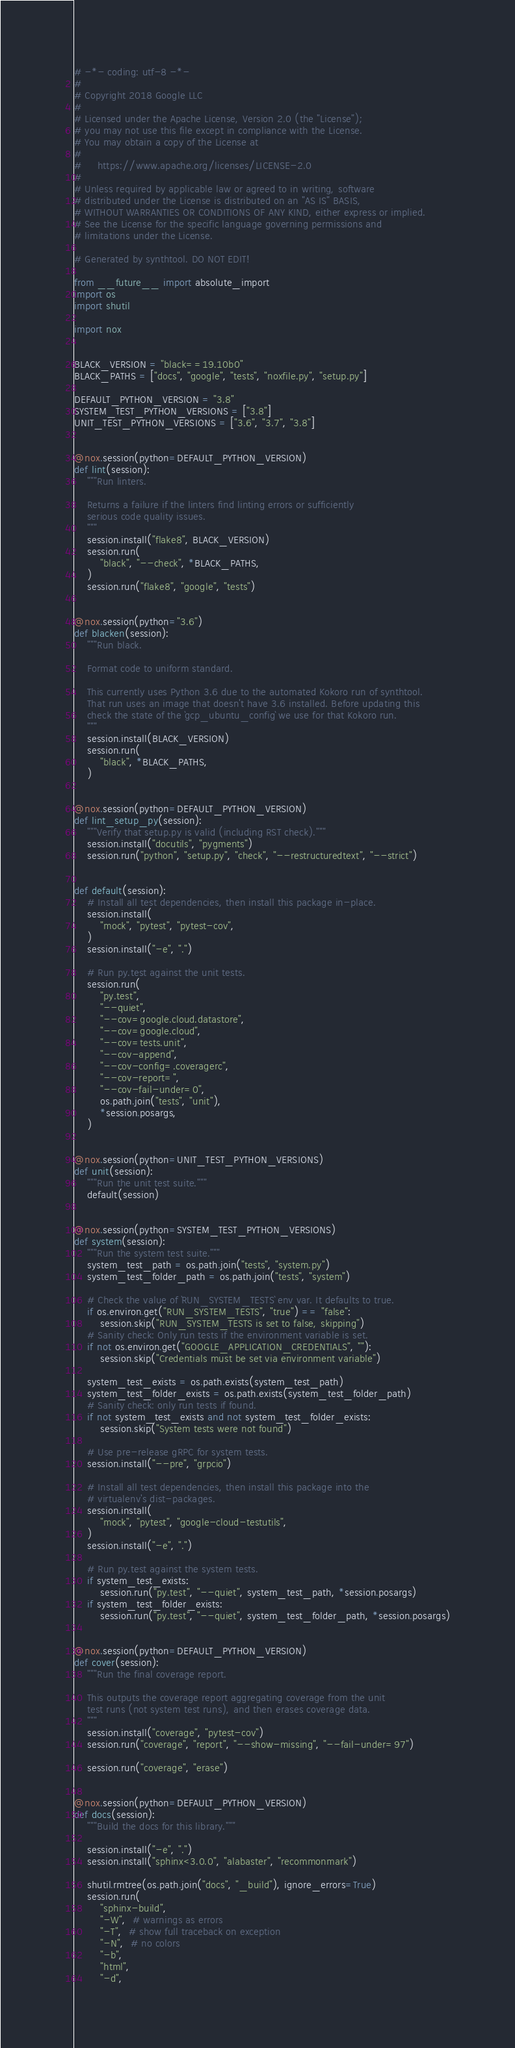<code> <loc_0><loc_0><loc_500><loc_500><_Python_># -*- coding: utf-8 -*-
#
# Copyright 2018 Google LLC
#
# Licensed under the Apache License, Version 2.0 (the "License");
# you may not use this file except in compliance with the License.
# You may obtain a copy of the License at
#
#     https://www.apache.org/licenses/LICENSE-2.0
#
# Unless required by applicable law or agreed to in writing, software
# distributed under the License is distributed on an "AS IS" BASIS,
# WITHOUT WARRANTIES OR CONDITIONS OF ANY KIND, either express or implied.
# See the License for the specific language governing permissions and
# limitations under the License.

# Generated by synthtool. DO NOT EDIT!

from __future__ import absolute_import
import os
import shutil

import nox


BLACK_VERSION = "black==19.10b0"
BLACK_PATHS = ["docs", "google", "tests", "noxfile.py", "setup.py"]

DEFAULT_PYTHON_VERSION = "3.8"
SYSTEM_TEST_PYTHON_VERSIONS = ["3.8"]
UNIT_TEST_PYTHON_VERSIONS = ["3.6", "3.7", "3.8"]


@nox.session(python=DEFAULT_PYTHON_VERSION)
def lint(session):
    """Run linters.

    Returns a failure if the linters find linting errors or sufficiently
    serious code quality issues.
    """
    session.install("flake8", BLACK_VERSION)
    session.run(
        "black", "--check", *BLACK_PATHS,
    )
    session.run("flake8", "google", "tests")


@nox.session(python="3.6")
def blacken(session):
    """Run black.

    Format code to uniform standard.

    This currently uses Python 3.6 due to the automated Kokoro run of synthtool.
    That run uses an image that doesn't have 3.6 installed. Before updating this
    check the state of the `gcp_ubuntu_config` we use for that Kokoro run.
    """
    session.install(BLACK_VERSION)
    session.run(
        "black", *BLACK_PATHS,
    )


@nox.session(python=DEFAULT_PYTHON_VERSION)
def lint_setup_py(session):
    """Verify that setup.py is valid (including RST check)."""
    session.install("docutils", "pygments")
    session.run("python", "setup.py", "check", "--restructuredtext", "--strict")


def default(session):
    # Install all test dependencies, then install this package in-place.
    session.install(
        "mock", "pytest", "pytest-cov",
    )
    session.install("-e", ".")

    # Run py.test against the unit tests.
    session.run(
        "py.test",
        "--quiet",
        "--cov=google.cloud.datastore",
        "--cov=google.cloud",
        "--cov=tests.unit",
        "--cov-append",
        "--cov-config=.coveragerc",
        "--cov-report=",
        "--cov-fail-under=0",
        os.path.join("tests", "unit"),
        *session.posargs,
    )


@nox.session(python=UNIT_TEST_PYTHON_VERSIONS)
def unit(session):
    """Run the unit test suite."""
    default(session)


@nox.session(python=SYSTEM_TEST_PYTHON_VERSIONS)
def system(session):
    """Run the system test suite."""
    system_test_path = os.path.join("tests", "system.py")
    system_test_folder_path = os.path.join("tests", "system")

    # Check the value of `RUN_SYSTEM_TESTS` env var. It defaults to true.
    if os.environ.get("RUN_SYSTEM_TESTS", "true") == "false":
        session.skip("RUN_SYSTEM_TESTS is set to false, skipping")
    # Sanity check: Only run tests if the environment variable is set.
    if not os.environ.get("GOOGLE_APPLICATION_CREDENTIALS", ""):
        session.skip("Credentials must be set via environment variable")

    system_test_exists = os.path.exists(system_test_path)
    system_test_folder_exists = os.path.exists(system_test_folder_path)
    # Sanity check: only run tests if found.
    if not system_test_exists and not system_test_folder_exists:
        session.skip("System tests were not found")

    # Use pre-release gRPC for system tests.
    session.install("--pre", "grpcio")

    # Install all test dependencies, then install this package into the
    # virtualenv's dist-packages.
    session.install(
        "mock", "pytest", "google-cloud-testutils",
    )
    session.install("-e", ".")

    # Run py.test against the system tests.
    if system_test_exists:
        session.run("py.test", "--quiet", system_test_path, *session.posargs)
    if system_test_folder_exists:
        session.run("py.test", "--quiet", system_test_folder_path, *session.posargs)


@nox.session(python=DEFAULT_PYTHON_VERSION)
def cover(session):
    """Run the final coverage report.

    This outputs the coverage report aggregating coverage from the unit
    test runs (not system test runs), and then erases coverage data.
    """
    session.install("coverage", "pytest-cov")
    session.run("coverage", "report", "--show-missing", "--fail-under=97")

    session.run("coverage", "erase")


@nox.session(python=DEFAULT_PYTHON_VERSION)
def docs(session):
    """Build the docs for this library."""

    session.install("-e", ".")
    session.install("sphinx<3.0.0", "alabaster", "recommonmark")

    shutil.rmtree(os.path.join("docs", "_build"), ignore_errors=True)
    session.run(
        "sphinx-build",
        "-W",  # warnings as errors
        "-T",  # show full traceback on exception
        "-N",  # no colors
        "-b",
        "html",
        "-d",</code> 